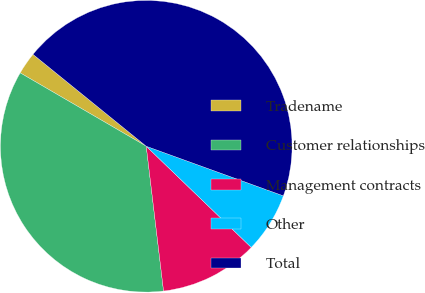<chart> <loc_0><loc_0><loc_500><loc_500><pie_chart><fcel>Tradename<fcel>Customer relationships<fcel>Management contracts<fcel>Other<fcel>Total<nl><fcel>2.46%<fcel>35.28%<fcel>10.9%<fcel>6.68%<fcel>44.67%<nl></chart> 